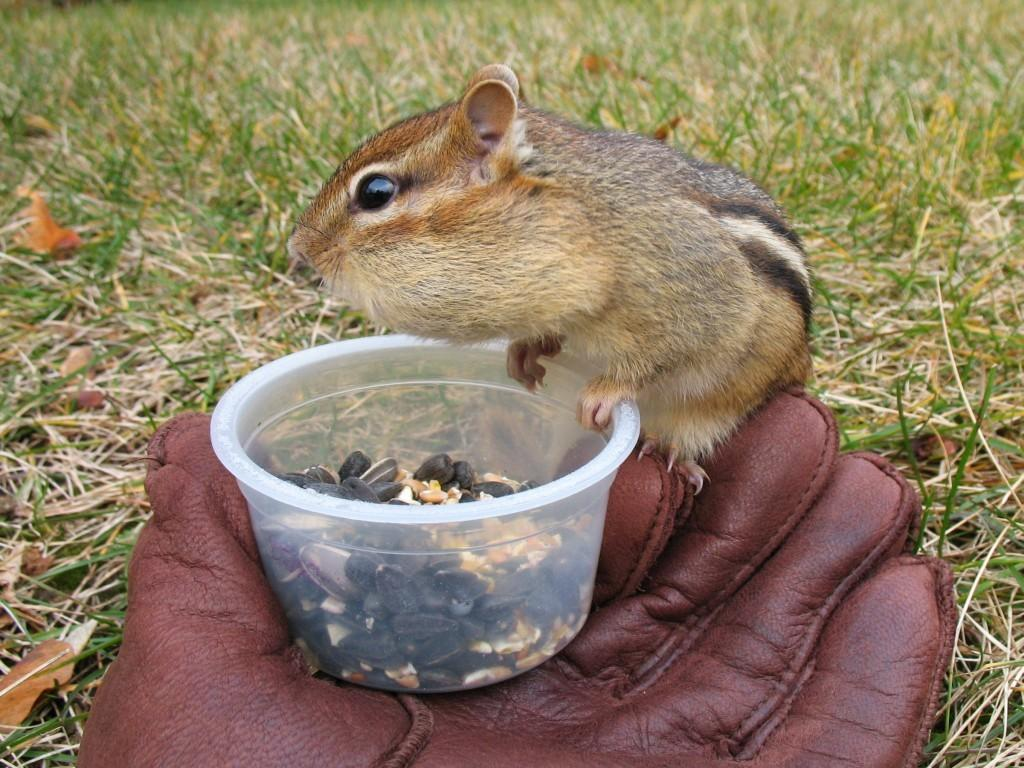What type of animal is in the image? The type of animal cannot be determined from the provided facts. What other objects are present in the image besides the animal? There is a glove and a bowl with grains in the image. What is the background of the image? The background of the image includes grass. How many volleyballs are being used by the animal in the image? There is no volleyball present in the image. What type of flower is being held by the animal in the image? There is no flower present in the image. 